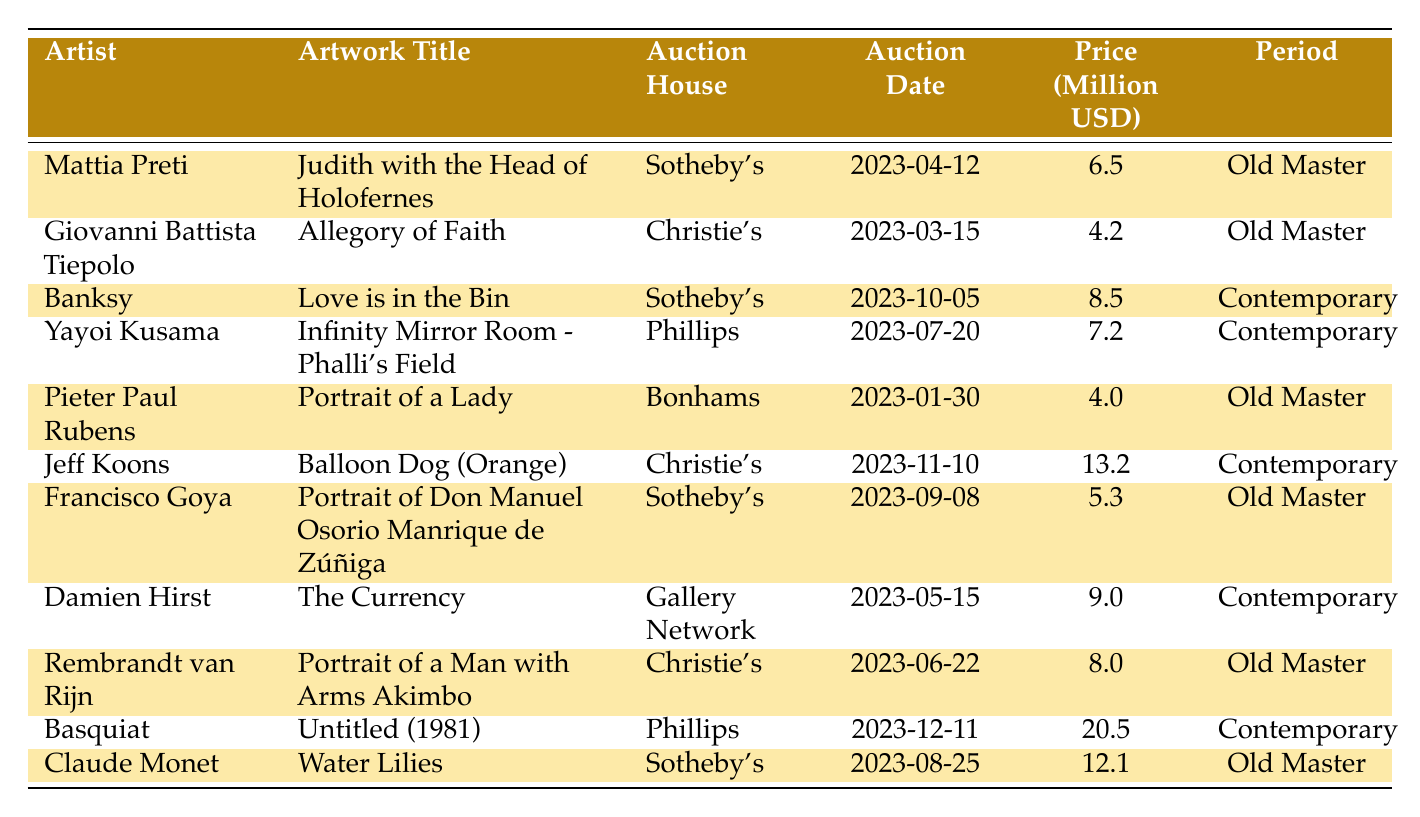What is the highest auction price among Old Master paintings? The highest auction price for Old Master paintings in the table is 12.1 million USD, which was for Claude Monet’s "Water Lilies"
Answer: 12.1 million USD Which auction house sold the artwork "Love is in the Bin"? The artwork "Love is in the Bin" was sold by Sotheby's
Answer: Sotheby's How many contemporary artworks were sold in the third quarter of the year (July, August, September)? There are two contemporary artworks sold in that period: Yayoi Kusama's "Infinity Mirror Room - Phalli's Field" on July 20 and Damien Hirst's "The Currency" on May 15; however, only Yayoi Kusama's is in the third quarter. So, the count is 1
Answer: 1 Is the auction date for Rembrandt van Rijn's painting before or after the auction date for Mattia Preti's painting? Rembrandt van Rijn's painting was auctioned on 2023-06-22, which is after Mattia Preti's auction on 2023-04-12
Answer: After What is the total auction price for all Old Master paintings listed in the table? The total price for Old Master paintings is calculated as follows: 6.5 + 4.2 + 4.0 + 5.3 + 8.0 + 12.1 = 40.1 million USD
Answer: 40.1 million USD Which artist had the lowest selling price in the table? The lowest selling price in the table belongs to Giovanni Battista Tiepolo, whose artwork "Allegory of Faith" sold for 4.2 million USD
Answer: Giovanni Battista Tiepolo What is the median auction price among the contemporary artworks listed? For contemporary artworks, the prices are 8.5, 7.2, 13.2, 9.0, and 20.5 million USD. When sorted, they are 7.2, 8.5, 9.0, 13.2, 20.5; the median is the middle value, which is 9.0 million USD
Answer: 9.0 million USD How many artists in the table have auctioned works priced above 10 million USD? There are three artists with auction prices over 10 million USD: Jeff Koons (13.2 million), Claude Monet (12.1 million), and Basquiat (20.5 million)
Answer: 3 What is the difference in auction price between the most expensive Old Master painting and the most expensive contemporary artwork? The most expensive Old Master painting is Claude Monet's "Water Lilies" at 12.1 million USD; the most expensive contemporary artwork is Basquiat's "Untitled (1981)" at 20.5 million USD. The difference is 20.5 - 12.1 = 8.4 million USD
Answer: 8.4 million USD Which period has the highest average auction price based on the data provided? The average auction prices are calculated as follows: Old Master (40.1 million / 6 artworks) = 6.68 million, and Contemporary (58.4 million / 5 artworks) = 11.68 million. Contemporary has a higher average
Answer: Contemporary 